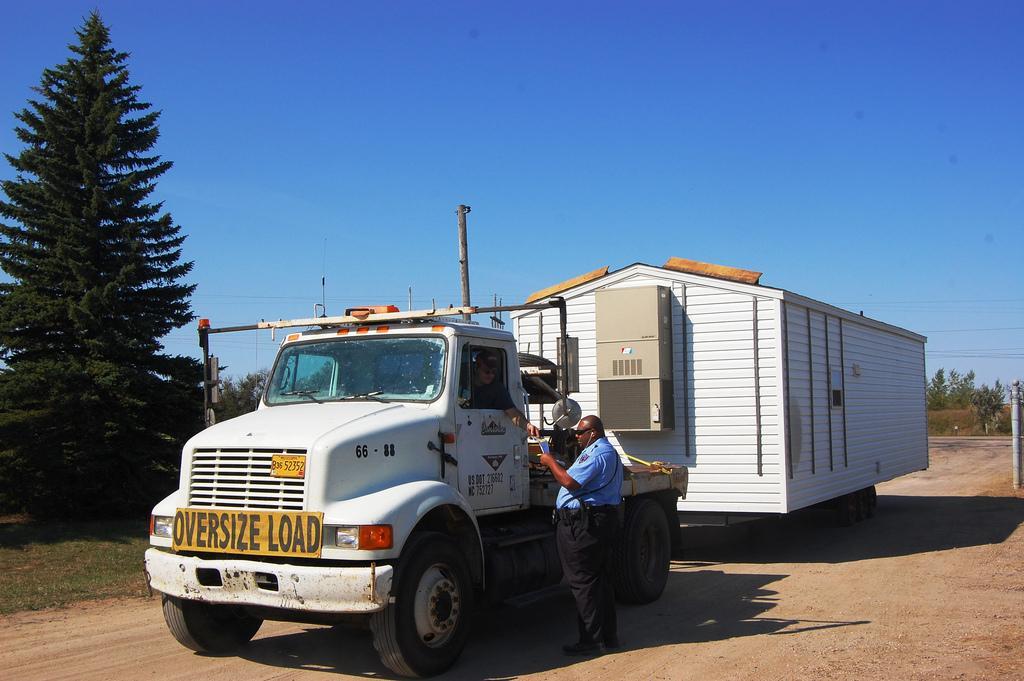Could you give a brief overview of what you see in this image? In this picture we can see a vehicle on the road, two people, grass, poles, trees, some objects and in the background we can see the sky. 